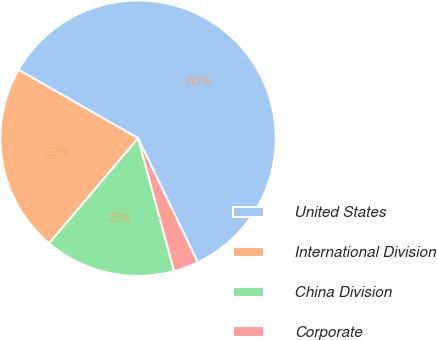<chart> <loc_0><loc_0><loc_500><loc_500><pie_chart><fcel>United States<fcel>International Division<fcel>China Division<fcel>Corporate<nl><fcel>59.6%<fcel>22.1%<fcel>15.4%<fcel>2.9%<nl></chart> 